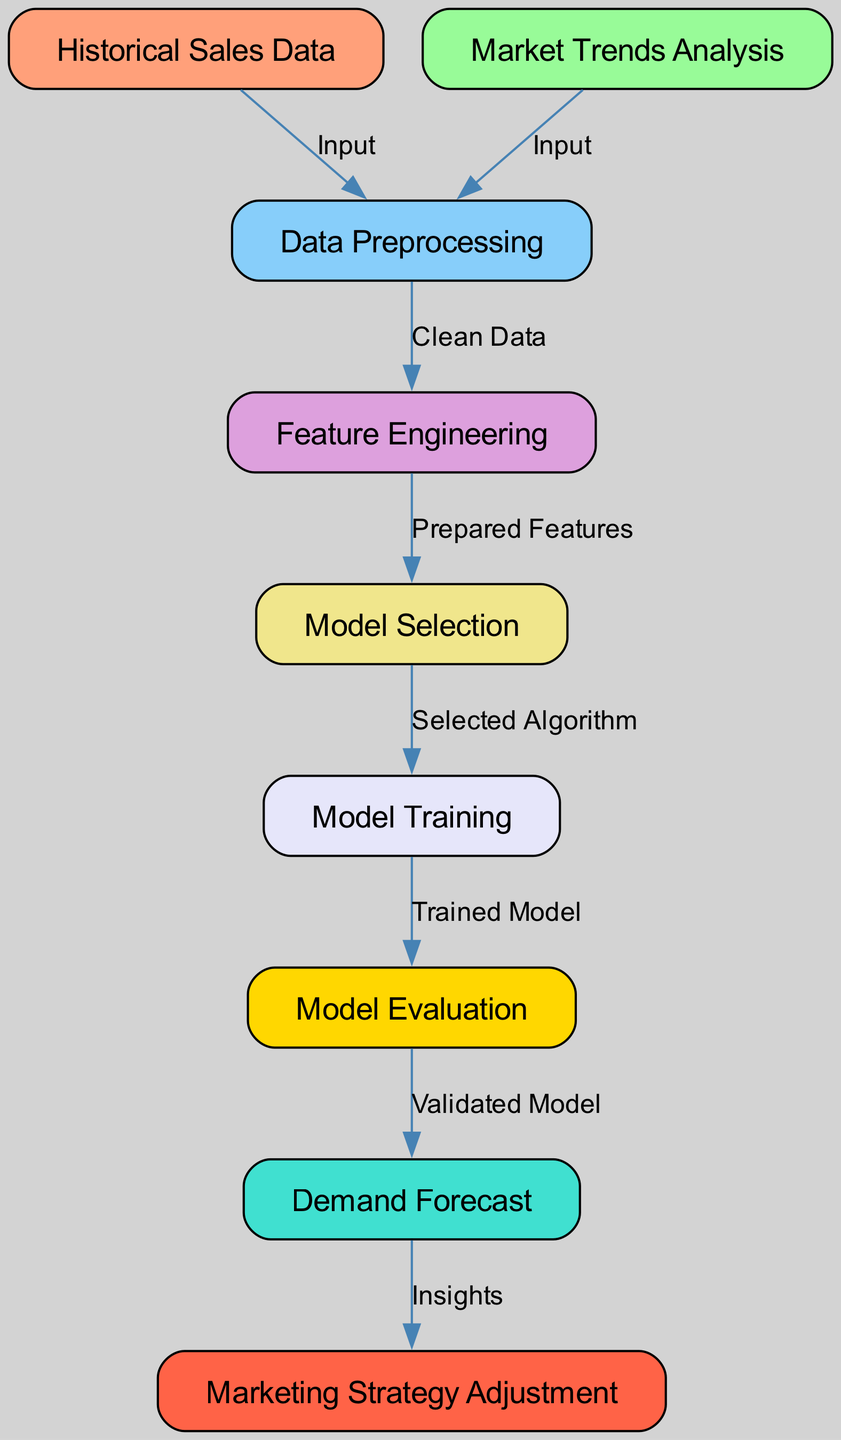What is the first node in the diagram? The first node in the diagram is "Historical Sales Data". It is the initial input that starts the workflow process.
Answer: Historical Sales Data How many nodes are shown in the diagram? The diagram shows a total of nine nodes, each representing a specific step in the predictive analytics workflow.
Answer: Nine What is the relationship between "Data Preprocessing" and "Feature Engineering"? The relationship is that "Data Preprocessing" provides clean data to "Feature Engineering", as indicated by the directed edge labeled "Clean Data".
Answer: Clean Data What node follows "Model Training"? The node that follows "Model Training" in the diagram is "Model Evaluation". This indicates that after the model is trained, it is evaluated for its performance.
Answer: Model Evaluation What is the final output of the predictive analytics workflow? The final output of the predictive analytics workflow is "Marketing Strategy Adjustment". This shows how the insights from demand forecasts are used to modify marketing strategies.
Answer: Marketing Strategy Adjustment Which two nodes provide input to "Data Preprocessing"? The nodes providing input to "Data Preprocessing" are "Historical Sales Data" and "Market Trends Analysis". Both are necessary to prepare the data for further analysis.
Answer: Historical Sales Data and Market Trends Analysis What is the flow from "Demand Forecast" to the next step in the process? The flow from "Demand Forecast" leads to "Marketing Strategy Adjustment", which indicates how demand predictions inform marketing decisions.
Answer: Marketing Strategy Adjustment What does the "Feature Engineering" node provide to "Model Selection"? The "Feature Engineering" node provides "Prepared Features" to "Model Selection", essential for choosing the appropriate algorithm for modeling.
Answer: Prepared Features Which node is directly fed by "Model Evaluation"? The node directly fed by "Model Evaluation" is "Demand Forecast". This indicates that evaluated models are utilized to forecast demand based on their performance.
Answer: Demand Forecast 